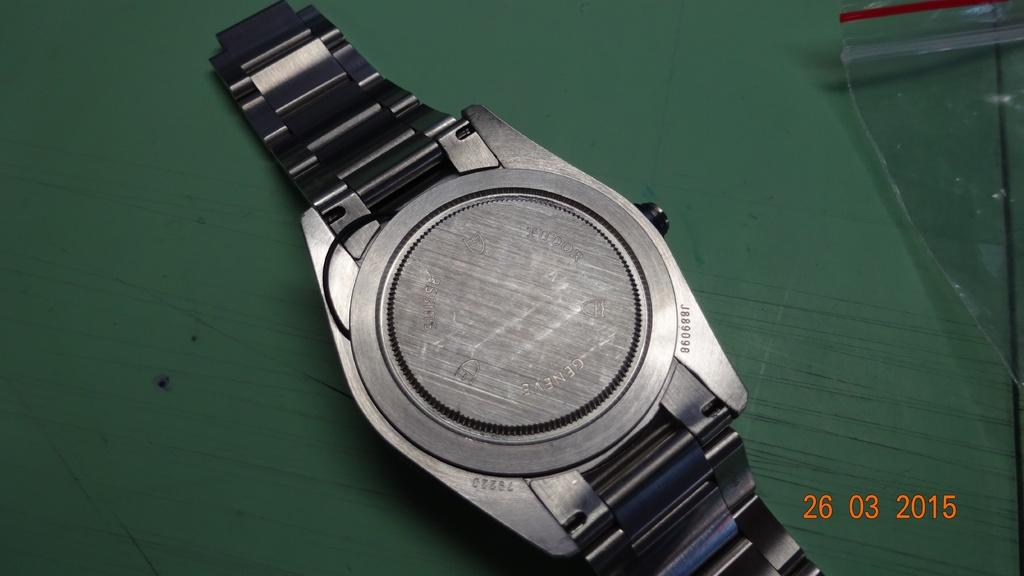Provide a one-sentence caption for the provided image. The back of a Geneve watch is shown in a photo from 2015. 